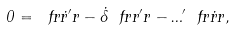Convert formula to latex. <formula><loc_0><loc_0><loc_500><loc_500>0 = \ f r { \dot { r } ^ { \prime } } { r } - \dot { \Lambda } \ f r { r ^ { \prime } } { r } - \Phi ^ { \prime } \ f r { \dot { r } } { r } ,</formula> 